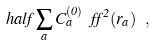Convert formula to latex. <formula><loc_0><loc_0><loc_500><loc_500>\ h a l f \sum _ { a } C ^ { ( 0 ) } _ { a } \ f f ^ { 2 } ( r _ { a } ) \ ,</formula> 